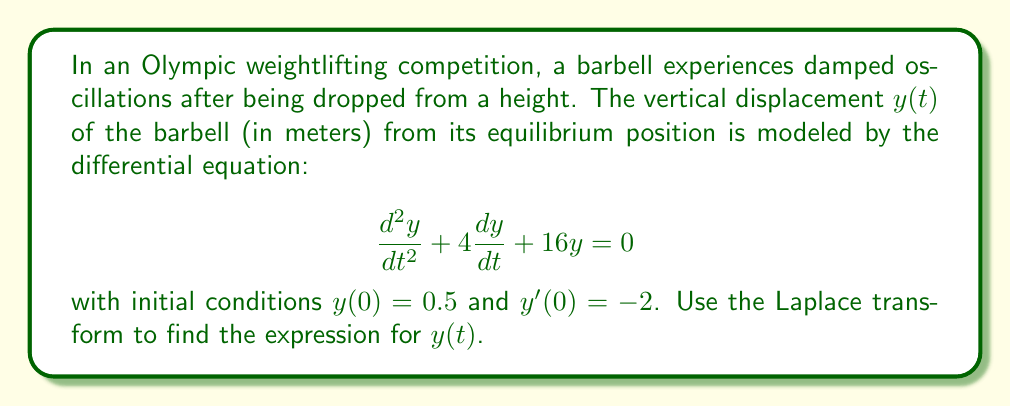Give your solution to this math problem. Let's solve this step-by-step using the Laplace transform:

1) Let $Y(s) = \mathcal{L}\{y(t)\}$. Taking the Laplace transform of both sides of the differential equation:

   $$\mathcal{L}\{\frac{d^2y}{dt^2} + 4\frac{dy}{dt} + 16y\} = \mathcal{L}\{0\}$$

2) Using Laplace transform properties:

   $$s^2Y(s) - sy(0) - y'(0) + 4[sY(s) - y(0)] + 16Y(s) = 0$$

3) Substituting the initial conditions $y(0) = 0.5$ and $y'(0) = -2$:

   $$s^2Y(s) - 0.5s + 2 + 4sY(s) - 2 + 16Y(s) = 0$$

4) Simplifying:

   $$(s^2 + 4s + 16)Y(s) = 0.5s$$

5) Solving for $Y(s)$:

   $$Y(s) = \frac{0.5s}{s^2 + 4s + 16}$$

6) This can be rewritten as:

   $$Y(s) = \frac{0.5s}{(s+2)^2 + 12}$$

7) This is in the form of the Laplace transform of a damped sinusoidal function. The inverse Laplace transform is:

   $$y(t) = 0.5e^{-2t}\cos(\sqrt{12}t) + \frac{1}{\sqrt{12}}e^{-2t}\sin(\sqrt{12}t)$$

8) Simplifying:

   $$y(t) = 0.5e^{-2t}\cos(2\sqrt{3}t) + \frac{1}{2\sqrt{3}}e^{-2t}\sin(2\sqrt{3}t)$$

This expression represents the vertical displacement of the barbell over time.
Answer: $$y(t) = 0.5e^{-2t}\cos(2\sqrt{3}t) + \frac{1}{2\sqrt{3}}e^{-2t}\sin(2\sqrt{3}t)$$ 